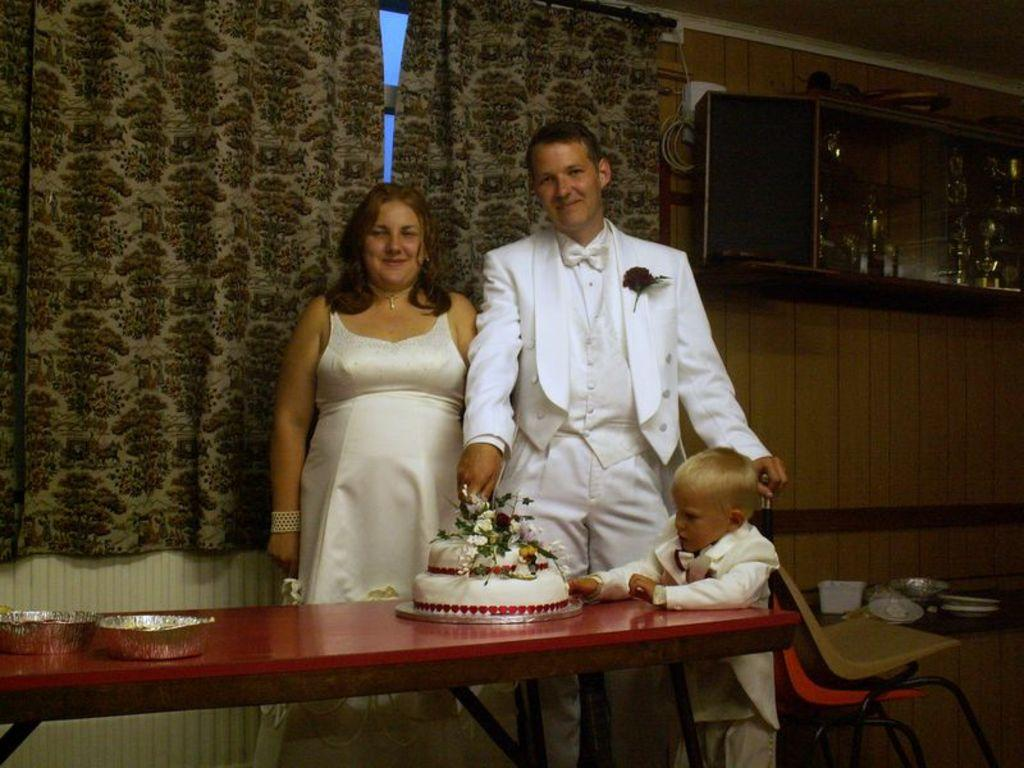What is on the table in the image? There is a bowl and a cake on the table in the image. Who or what is near the table? People are standing near the table. What can be seen in the background of the image? There are curtains and a shelf in the background. What furniture is beside the table? There are chairs beside the table. What type of paste is being used by the people in the image? There is no paste visible or mentioned in the image. What scientific experiment is being conducted in the image? There is no scientific experiment depicted in the image. 